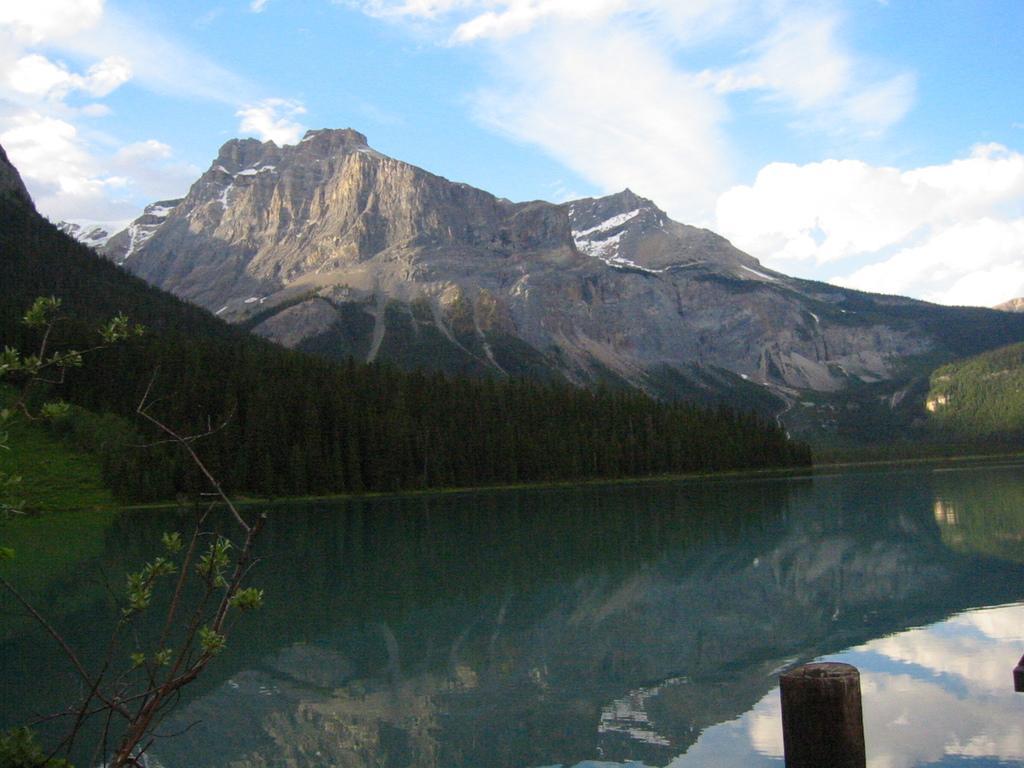Describe this image in one or two sentences. In this image I can see water, trees and mountains. At the top I can see the blue sky. This image is taken may be near the mountains. 